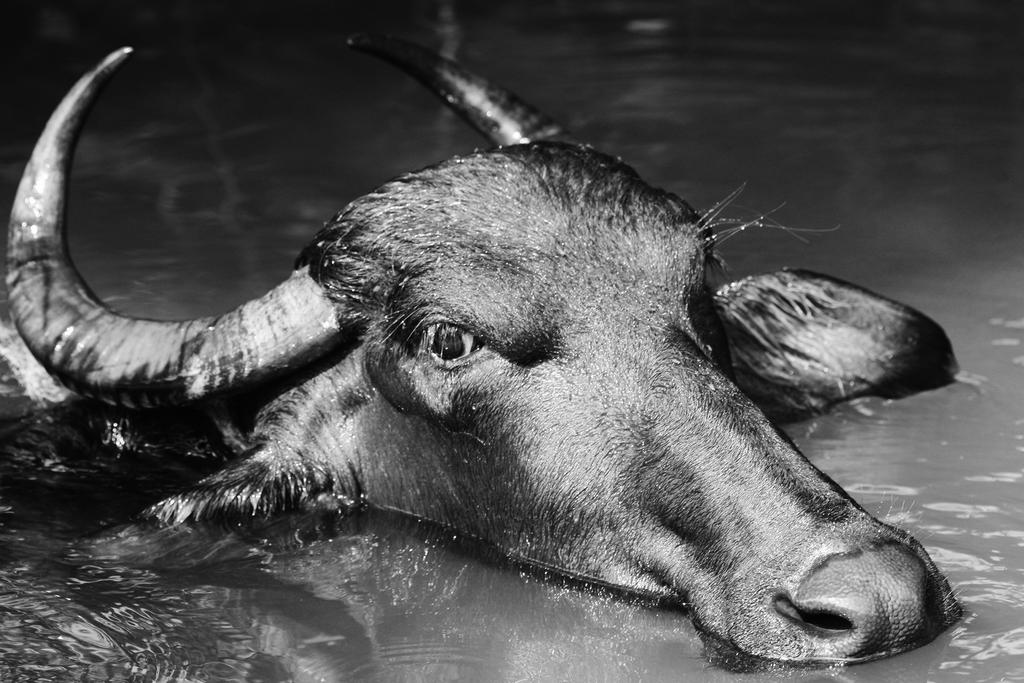What animal is present in the image? There is a buffalo in the image. What is the color of the buffalo? The buffalo is black in color. Where is the buffalo located in the image? The buffalo is in the water. What is visible in the image besides the buffalo? There is water visible in the image. Where is the drain located in the image? There is no drain present in the image. What trick is the buffalo performing in the image? The buffalo is not performing any tricks in the image; it is simply standing in the water. 